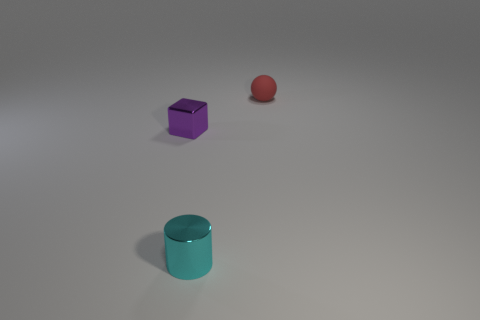Add 2 cyan cubes. How many objects exist? 5 Add 3 big cyan shiny balls. How many big cyan shiny balls exist? 3 Subtract 0 blue cubes. How many objects are left? 3 Subtract all cylinders. How many objects are left? 2 Subtract 1 cubes. How many cubes are left? 0 Subtract all red cylinders. Subtract all brown spheres. How many cylinders are left? 1 Subtract all red matte objects. Subtract all small shiny blocks. How many objects are left? 1 Add 1 tiny matte objects. How many tiny matte objects are left? 2 